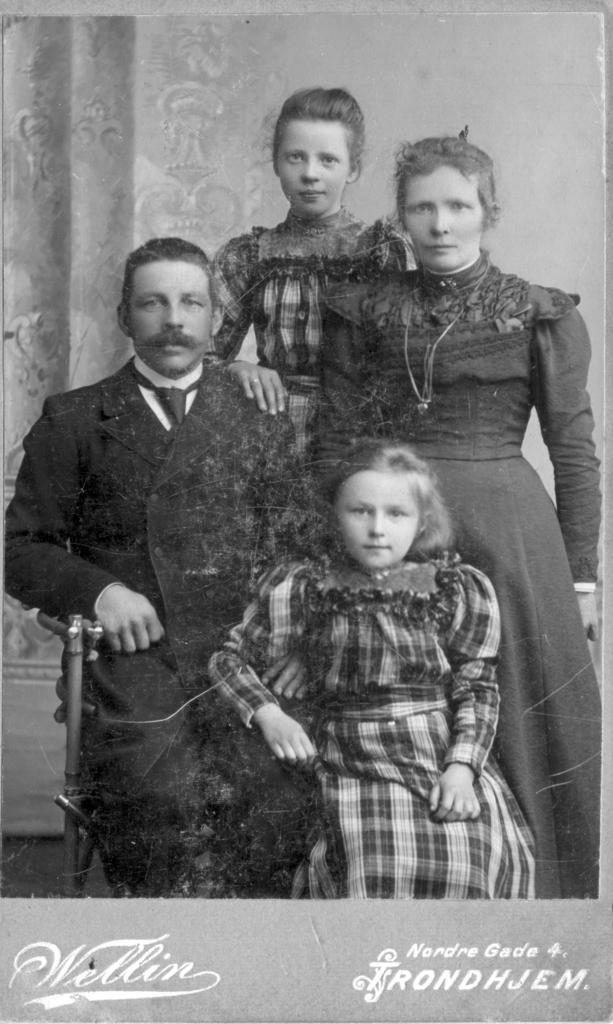What is the main subject of the image? The main subject of the image is a photograph. Who or what is depicted in the photograph? The photograph contains a man, a lady, and two girls. What is written or displayed at the bottom of the image? There is text at the bottom of the image. What type of dress is the mass wearing in the image? There is no mass or dress present in the image. The image contains a photograph with a man, a lady, and two girls, but no mention of a mass or dress. 